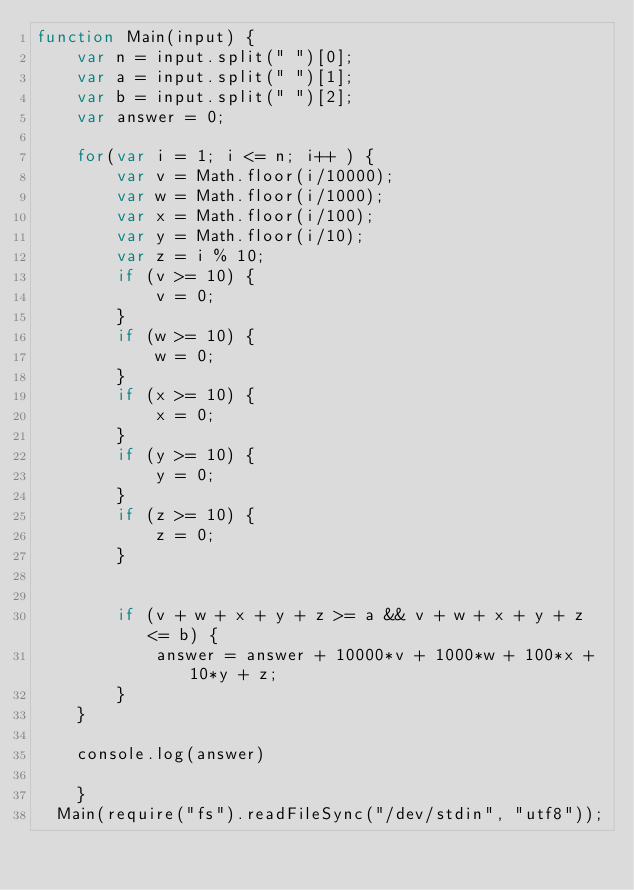<code> <loc_0><loc_0><loc_500><loc_500><_JavaScript_>function Main(input) {
    var n = input.split(" ")[0];
    var a = input.split(" ")[1];
    var b = input.split(" ")[2];
    var answer = 0;

    for(var i = 1; i <= n; i++ ) {
        var v = Math.floor(i/10000);
        var w = Math.floor(i/1000);
        var x = Math.floor(i/100);
        var y = Math.floor(i/10);
        var z = i % 10;
        if (v >= 10) {
            v = 0;
        }
        if (w >= 10) {
            w = 0;
        }
        if (x >= 10) {
            x = 0;
        }
        if (y >= 10) {
            y = 0;
        }
        if (z >= 10) {
            z = 0;
        }


        if (v + w + x + y + z >= a && v + w + x + y + z <= b) {
            answer = answer + 10000*v + 1000*w + 100*x + 10*y + z;
        }
    }

    console.log(answer)
  
    }
  Main(require("fs").readFileSync("/dev/stdin", "utf8"));
  </code> 